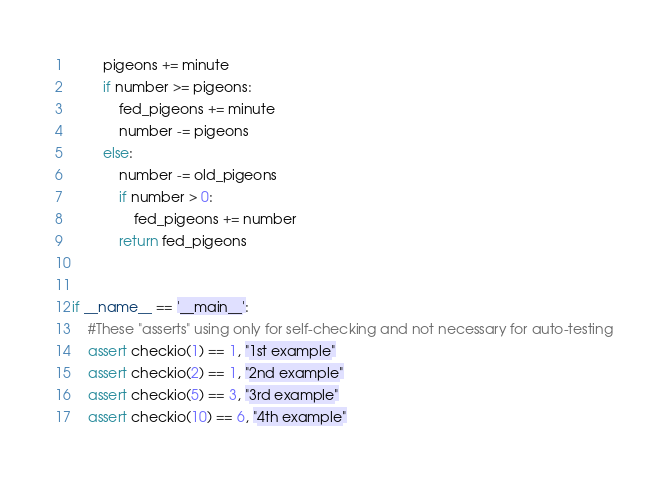Convert code to text. <code><loc_0><loc_0><loc_500><loc_500><_Python_>        pigeons += minute
        if number >= pigeons:
            fed_pigeons += minute
            number -= pigeons
        else:
            number -= old_pigeons
            if number > 0:
                fed_pigeons += number
            return fed_pigeons


if __name__ == '__main__':
    #These "asserts" using only for self-checking and not necessary for auto-testing
    assert checkio(1) == 1, "1st example"
    assert checkio(2) == 1, "2nd example"
    assert checkio(5) == 3, "3rd example"
    assert checkio(10) == 6, "4th example"</code> 